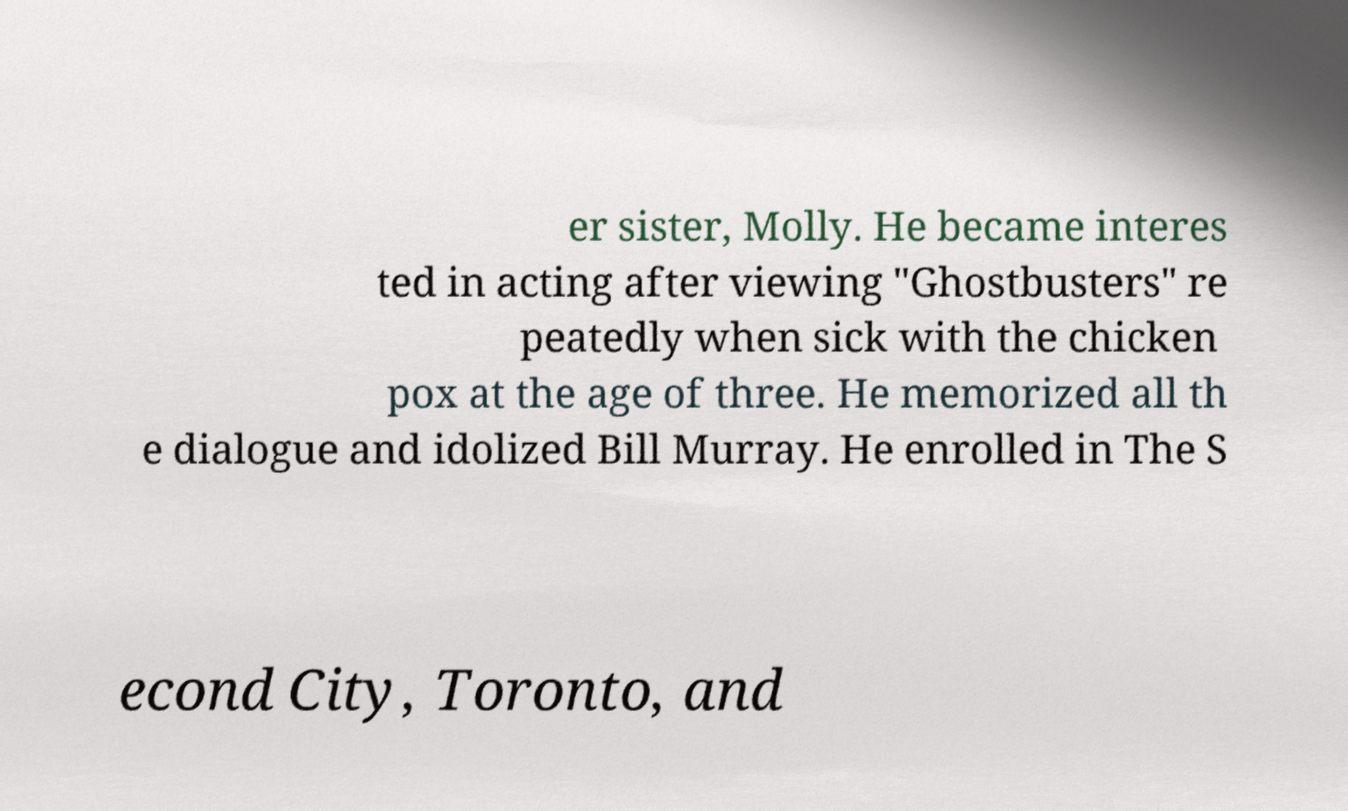I need the written content from this picture converted into text. Can you do that? er sister, Molly. He became interes ted in acting after viewing "Ghostbusters" re peatedly when sick with the chicken pox at the age of three. He memorized all th e dialogue and idolized Bill Murray. He enrolled in The S econd City, Toronto, and 